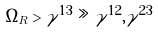Convert formula to latex. <formula><loc_0><loc_0><loc_500><loc_500>\Omega _ { R } > \gamma ^ { 1 3 } \gg \gamma ^ { 1 2 } , \gamma ^ { 2 3 }</formula> 